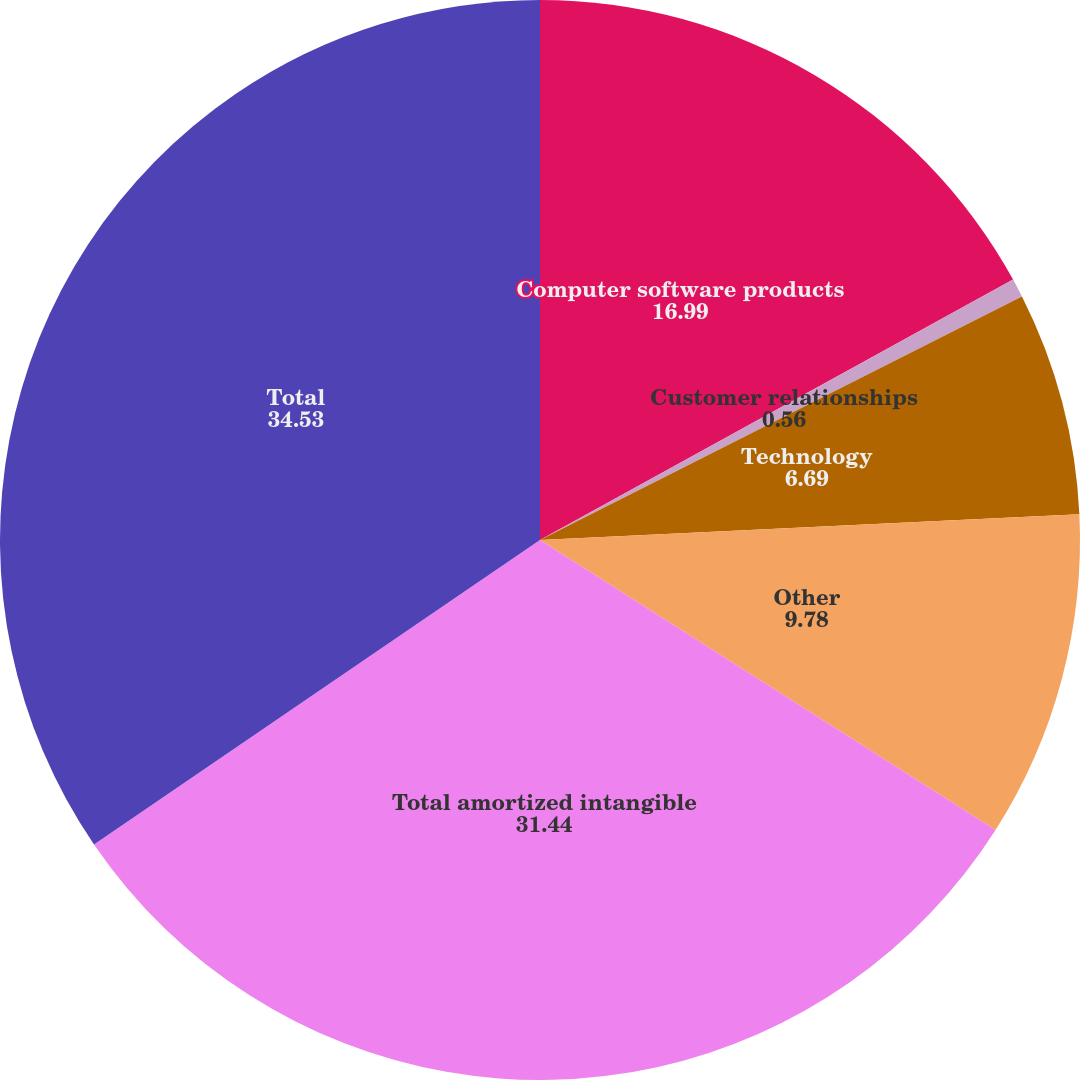Convert chart. <chart><loc_0><loc_0><loc_500><loc_500><pie_chart><fcel>Computer software products<fcel>Customer relationships<fcel>Technology<fcel>Other<fcel>Total amortized intangible<fcel>Total<nl><fcel>16.99%<fcel>0.56%<fcel>6.69%<fcel>9.78%<fcel>31.44%<fcel>34.53%<nl></chart> 